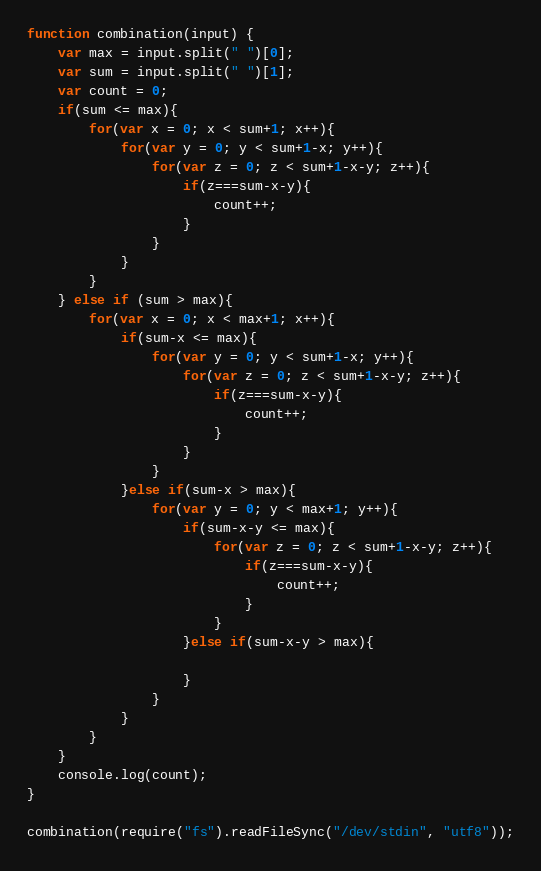Convert code to text. <code><loc_0><loc_0><loc_500><loc_500><_JavaScript_>function combination(input) {
	var max = input.split(" ")[0];
	var sum = input.split(" ")[1];
	var count = 0;
	if(sum <= max){
		for(var x = 0; x < sum+1; x++){
			for(var y = 0; y < sum+1-x; y++){
				for(var z = 0; z < sum+1-x-y; z++){
					if(z===sum-x-y){
						count++;
					}
				}
			}
		}
	} else if (sum > max){
		for(var x = 0; x < max+1; x++){
			if(sum-x <= max){
				for(var y = 0; y < sum+1-x; y++){
					for(var z = 0; z < sum+1-x-y; z++){
						if(z===sum-x-y){
							count++;
						}
					}
				}
			}else if(sum-x > max){
				for(var y = 0; y < max+1; y++){
					if(sum-x-y <= max){
						for(var z = 0; z < sum+1-x-y; z++){
							if(z===sum-x-y){
								count++;
							}
						}
					}else if(sum-x-y > max){

					}
				}
			}
		}
	}
	console.log(count);
}

combination(require("fs").readFileSync("/dev/stdin", "utf8"));</code> 